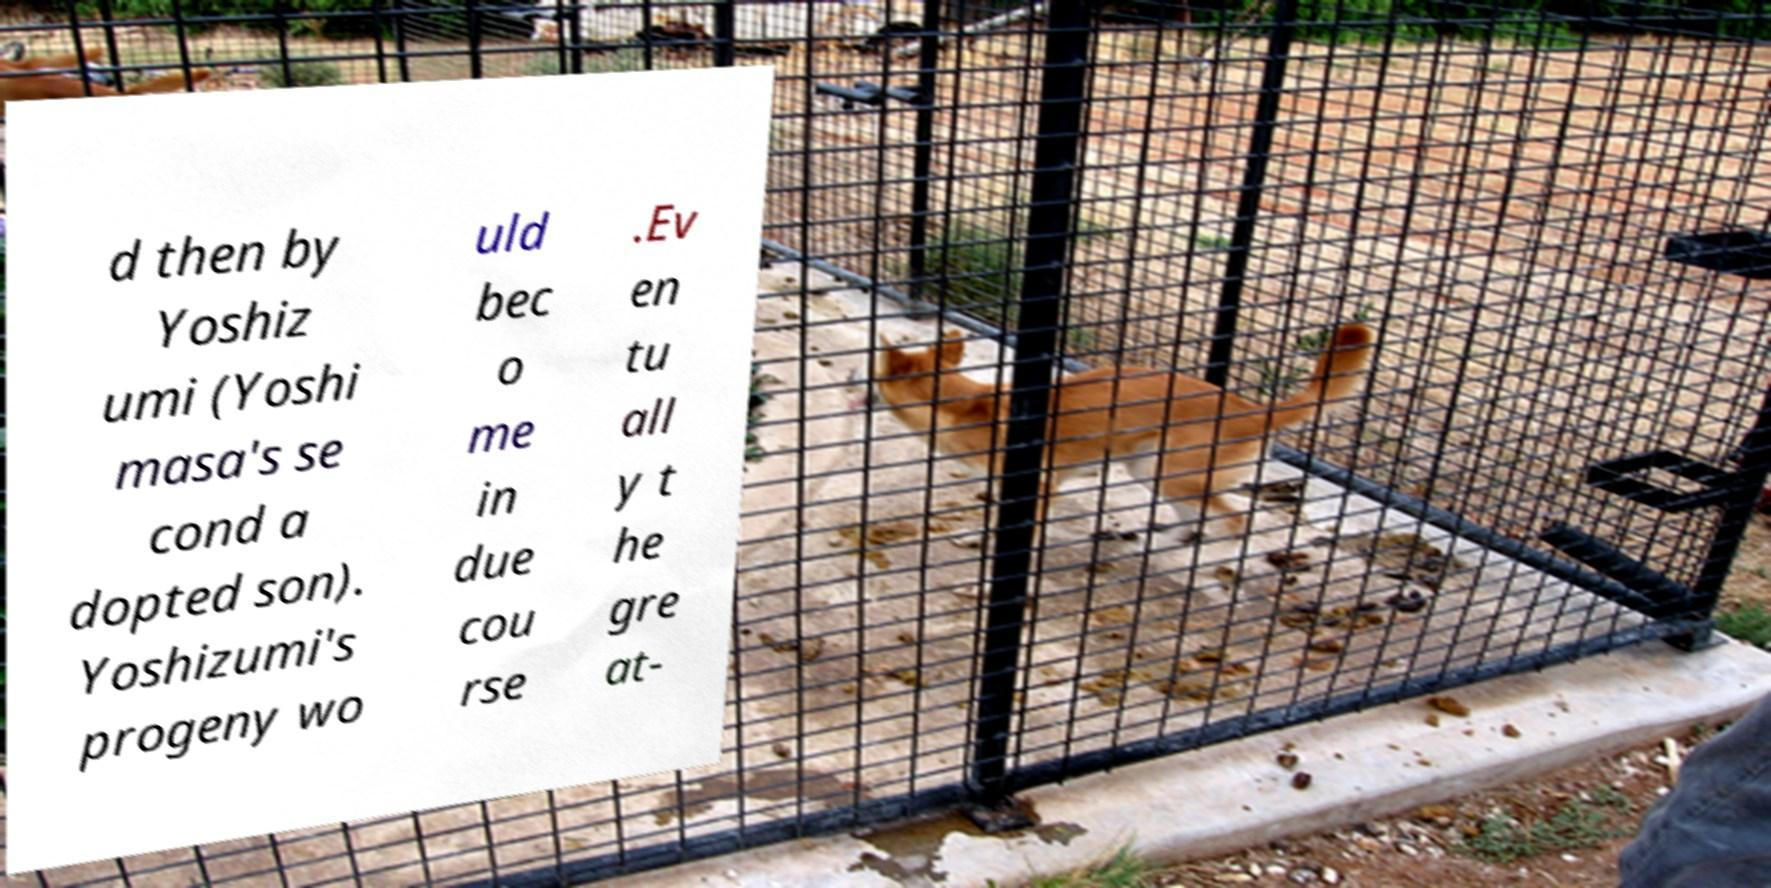What messages or text are displayed in this image? I need them in a readable, typed format. d then by Yoshiz umi (Yoshi masa's se cond a dopted son). Yoshizumi's progeny wo uld bec o me in due cou rse .Ev en tu all y t he gre at- 